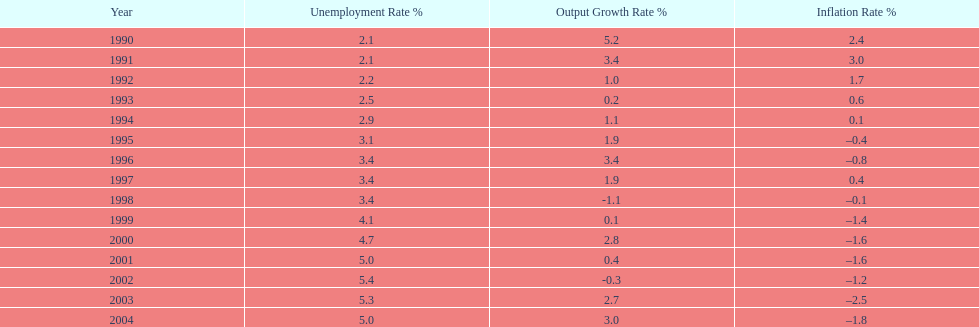When in the 1990's did the inflation rate first become negative? 1995. 